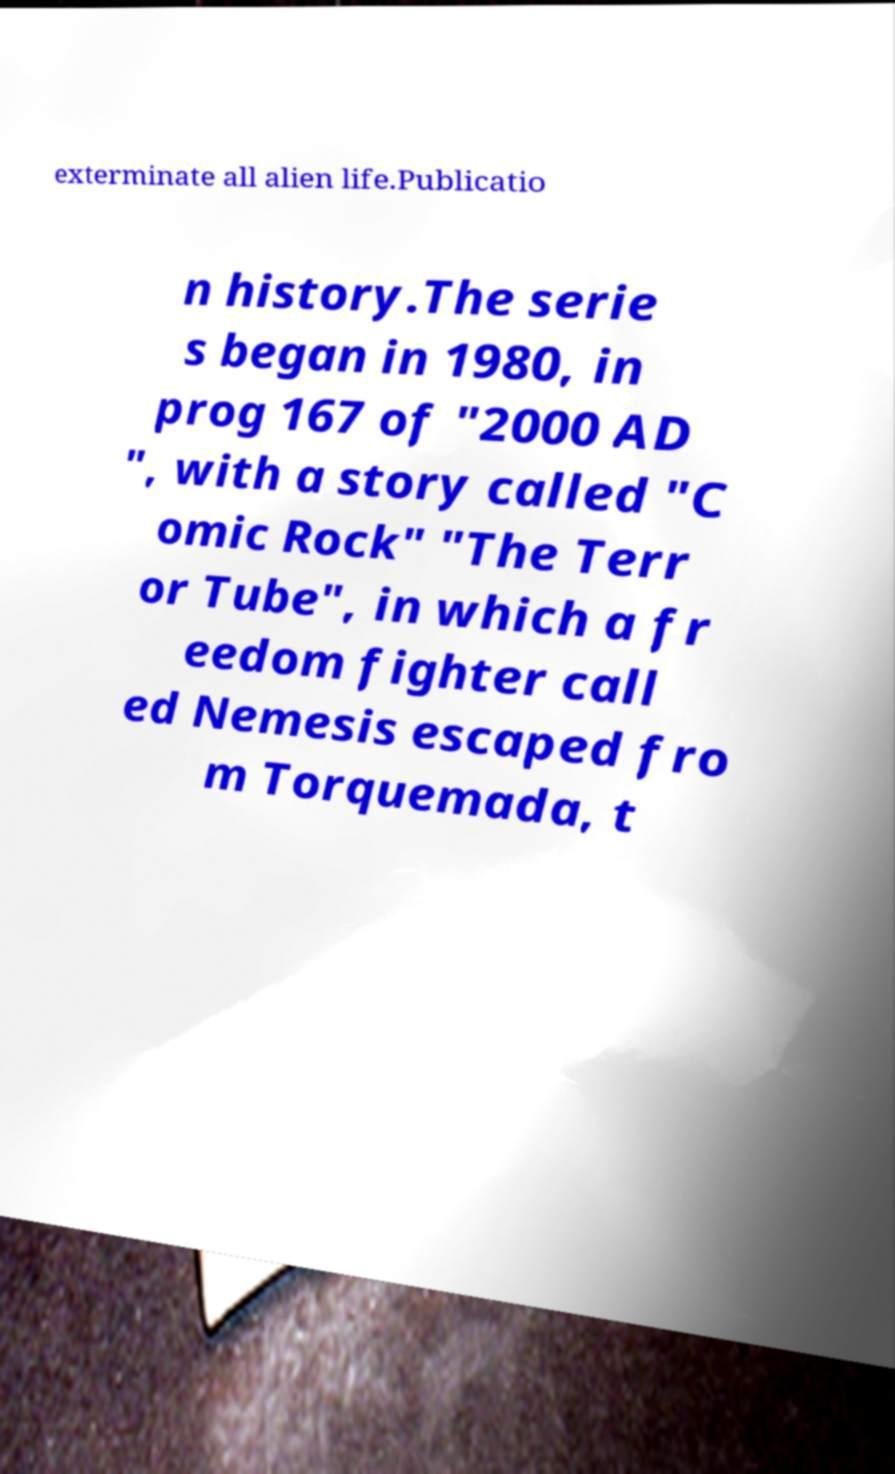Could you extract and type out the text from this image? exterminate all alien life.Publicatio n history.The serie s began in 1980, in prog 167 of "2000 AD ", with a story called "C omic Rock" "The Terr or Tube", in which a fr eedom fighter call ed Nemesis escaped fro m Torquemada, t 